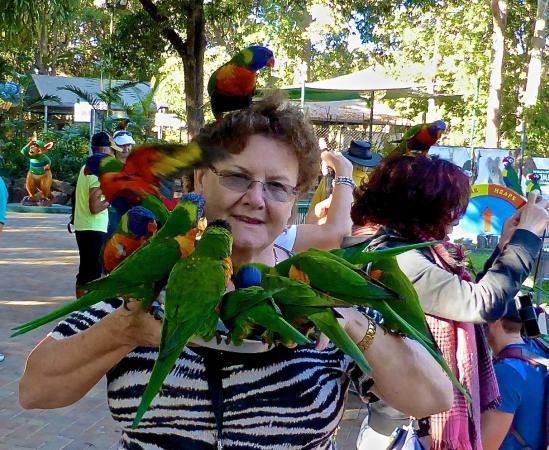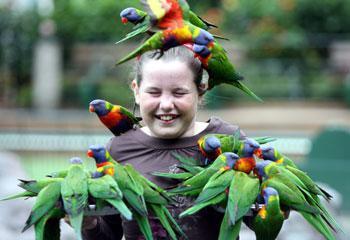The first image is the image on the left, the second image is the image on the right. Given the left and right images, does the statement "The birds are only drinking water in one of the iages." hold true? Answer yes or no. No. The first image is the image on the left, the second image is the image on the right. Assess this claim about the two images: "birds are standing on a green platform with a bowl in the center on a blacktop sidewalk". Correct or not? Answer yes or no. No. 